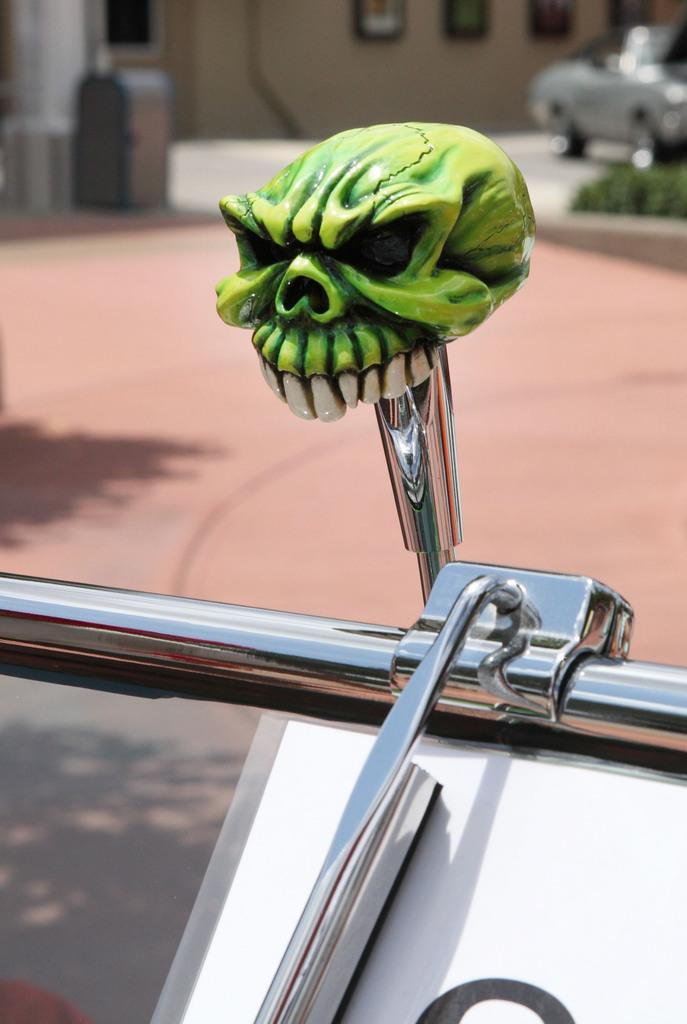What is the main object in the image? There is a green color skull toy in the image. How is the skull toy positioned? The skull toy is on a stainless rod. What can be seen at the top of the image? There is a car and a wall at the top of the image. What type of frame is around the zebra in the image? There is no zebra present in the image, so there is no frame around a zebra. 